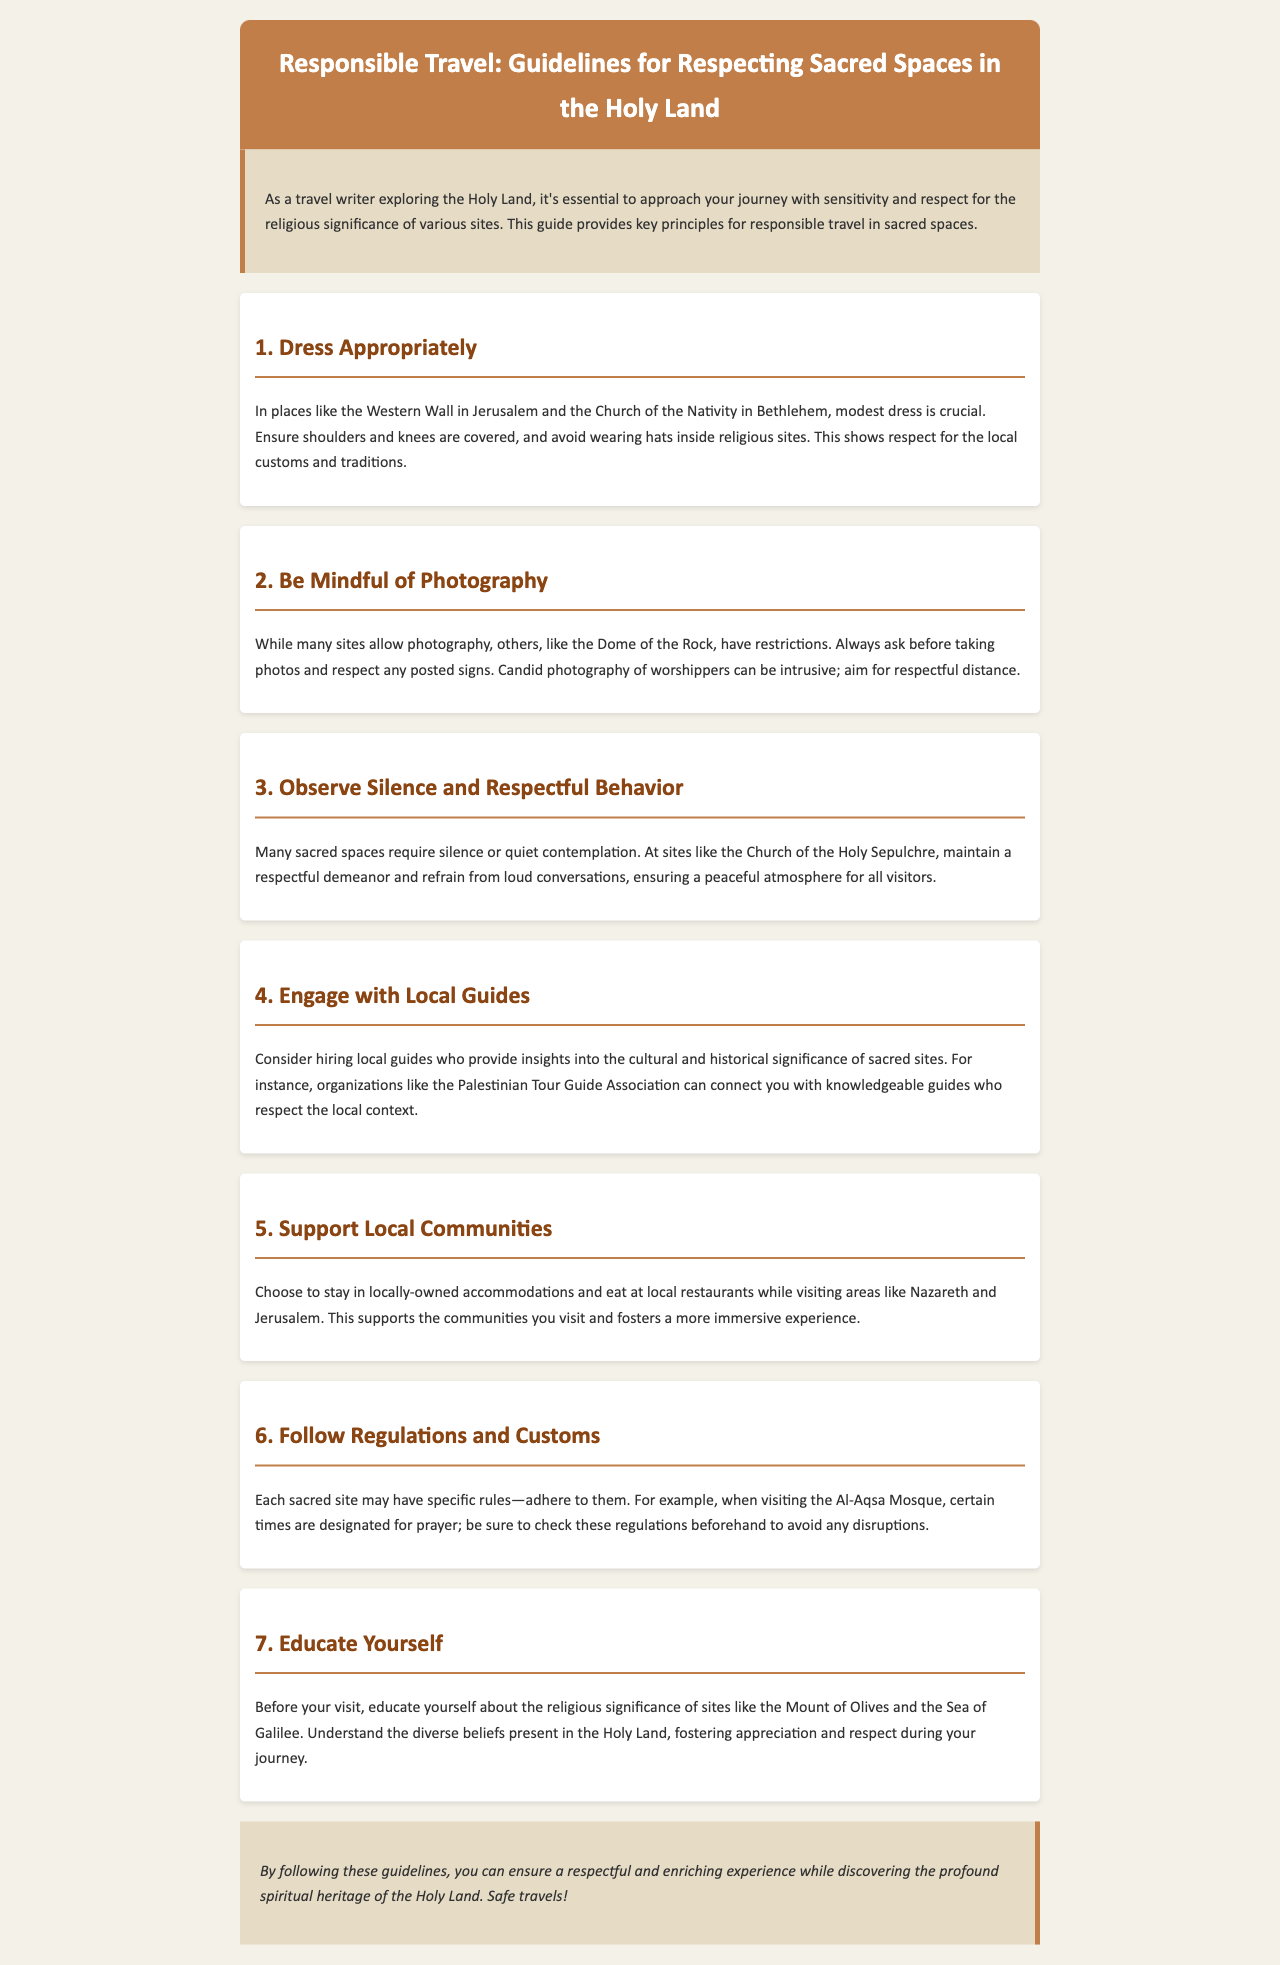what is the title of the document? The title is prominently displayed at the top of the document.
Answer: Responsible Travel: Guidelines for Respecting Sacred Spaces in the Holy Land what is a key principle for visiting the Western Wall? The document mentions that modest dress is crucial when visiting the Western Wall.
Answer: Dress Appropriately which site requires silence and respectful behavior? The document specifically mentions the Church of the Holy Sepulchre for this principle.
Answer: Church of the Holy Sepulchre how should visitors engage with local culture? The document suggests hiring local guides for insights into sacred sites.
Answer: Engage with Local Guides what is recommended when visiting the Al-Aqsa Mosque? The document states that certain times are designated for prayer at the Al-Aqsa Mosque.
Answer: Follow Regulations and Customs why is it important to support local communities? Supporting local communities fosters a more immersive experience according to the document.
Answer: Support Local Communities how many key principles are outlined in the document? The document lists a total of seven principles for responsible travel.
Answer: Seven what is the background color of the closing section? The closing section is noted for having a specific background color in the document.
Answer: E6DCC6 